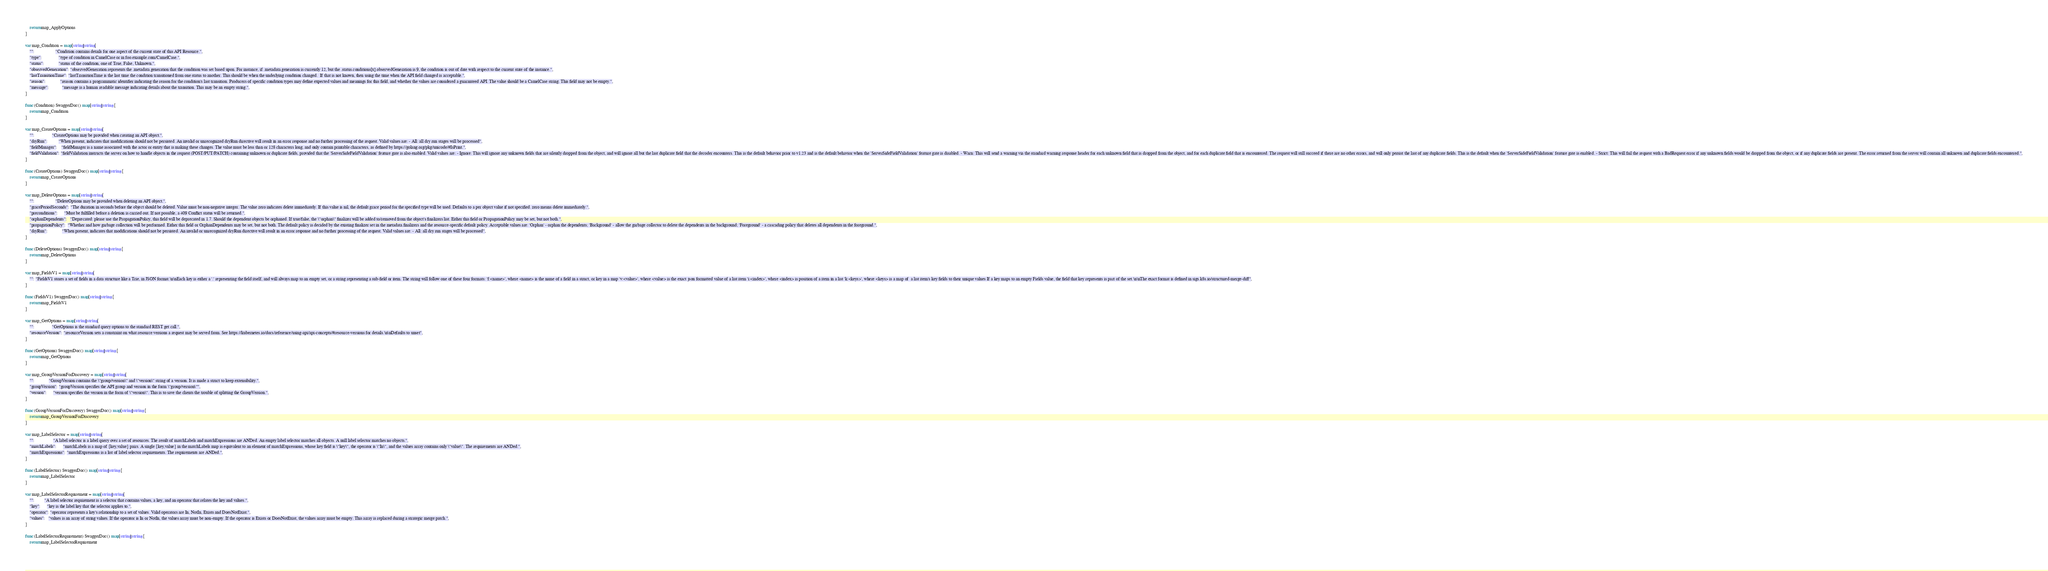Convert code to text. <code><loc_0><loc_0><loc_500><loc_500><_Go_>	return map_ApplyOptions
}

var map_Condition = map[string]string{
	"":                   "Condition contains details for one aspect of the current state of this API Resource.",
	"type":               "type of condition in CamelCase or in foo.example.com/CamelCase.",
	"status":             "status of the condition, one of True, False, Unknown.",
	"observedGeneration": "observedGeneration represents the .metadata.generation that the condition was set based upon. For instance, if .metadata.generation is currently 12, but the .status.conditions[x].observedGeneration is 9, the condition is out of date with respect to the current state of the instance.",
	"lastTransitionTime": "lastTransitionTime is the last time the condition transitioned from one status to another. This should be when the underlying condition changed.  If that is not known, then using the time when the API field changed is acceptable.",
	"reason":             "reason contains a programmatic identifier indicating the reason for the condition's last transition. Producers of specific condition types may define expected values and meanings for this field, and whether the values are considered a guaranteed API. The value should be a CamelCase string. This field may not be empty.",
	"message":            "message is a human readable message indicating details about the transition. This may be an empty string.",
}

func (Condition) SwaggerDoc() map[string]string {
	return map_Condition
}

var map_CreateOptions = map[string]string{
	"":                "CreateOptions may be provided when creating an API object.",
	"dryRun":          "When present, indicates that modifications should not be persisted. An invalid or unrecognized dryRun directive will result in an error response and no further processing of the request. Valid values are: - All: all dry run stages will be processed",
	"fieldManager":    "fieldManager is a name associated with the actor or entity that is making these changes. The value must be less than or 128 characters long, and only contain printable characters, as defined by https://golang.org/pkg/unicode/#IsPrint.",
	"fieldValidation": "fieldValidation instructs the server on how to handle objects in the request (POST/PUT/PATCH) containing unknown or duplicate fields, provided that the `ServerSideFieldValidation` feature gate is also enabled. Valid values are: - Ignore: This will ignore any unknown fields that are silently dropped from the object, and will ignore all but the last duplicate field that the decoder encounters. This is the default behavior prior to v1.23 and is the default behavior when the `ServerSideFieldValidation` feature gate is disabled. - Warn: This will send a warning via the standard warning response header for each unknown field that is dropped from the object, and for each duplicate field that is encountered. The request will still succeed if there are no other errors, and will only persist the last of any duplicate fields. This is the default when the `ServerSideFieldValidation` feature gate is enabled. - Strict: This will fail the request with a BadRequest error if any unknown fields would be dropped from the object, or if any duplicate fields are present. The error returned from the server will contain all unknown and duplicate fields encountered.",
}

func (CreateOptions) SwaggerDoc() map[string]string {
	return map_CreateOptions
}

var map_DeleteOptions = map[string]string{
	"":                   "DeleteOptions may be provided when deleting an API object.",
	"gracePeriodSeconds": "The duration in seconds before the object should be deleted. Value must be non-negative integer. The value zero indicates delete immediately. If this value is nil, the default grace period for the specified type will be used. Defaults to a per object value if not specified. zero means delete immediately.",
	"preconditions":      "Must be fulfilled before a deletion is carried out. If not possible, a 409 Conflict status will be returned.",
	"orphanDependents":   "Deprecated: please use the PropagationPolicy, this field will be deprecated in 1.7. Should the dependent objects be orphaned. If true/false, the \"orphan\" finalizer will be added to/removed from the object's finalizers list. Either this field or PropagationPolicy may be set, but not both.",
	"propagationPolicy":  "Whether and how garbage collection will be performed. Either this field or OrphanDependents may be set, but not both. The default policy is decided by the existing finalizer set in the metadata.finalizers and the resource-specific default policy. Acceptable values are: 'Orphan' - orphan the dependents; 'Background' - allow the garbage collector to delete the dependents in the background; 'Foreground' - a cascading policy that deletes all dependents in the foreground.",
	"dryRun":             "When present, indicates that modifications should not be persisted. An invalid or unrecognized dryRun directive will result in an error response and no further processing of the request. Valid values are: - All: all dry run stages will be processed",
}

func (DeleteOptions) SwaggerDoc() map[string]string {
	return map_DeleteOptions
}

var map_FieldsV1 = map[string]string{
	"": "FieldsV1 stores a set of fields in a data structure like a Trie, in JSON format.\n\nEach key is either a '.' representing the field itself, and will always map to an empty set, or a string representing a sub-field or item. The string will follow one of these four formats: 'f:<name>', where <name> is the name of a field in a struct, or key in a map 'v:<value>', where <value> is the exact json formatted value of a list item 'i:<index>', where <index> is position of a item in a list 'k:<keys>', where <keys> is a map of  a list item's key fields to their unique values If a key maps to an empty Fields value, the field that key represents is part of the set.\n\nThe exact format is defined in sigs.k8s.io/structured-merge-diff",
}

func (FieldsV1) SwaggerDoc() map[string]string {
	return map_FieldsV1
}

var map_GetOptions = map[string]string{
	"":                "GetOptions is the standard query options to the standard REST get call.",
	"resourceVersion": "resourceVersion sets a constraint on what resource versions a request may be served from. See https://kubernetes.io/docs/reference/using-api/api-concepts/#resource-versions for details.\n\nDefaults to unset",
}

func (GetOptions) SwaggerDoc() map[string]string {
	return map_GetOptions
}

var map_GroupVersionForDiscovery = map[string]string{
	"":             "GroupVersion contains the \"group/version\" and \"version\" string of a version. It is made a struct to keep extensibility.",
	"groupVersion": "groupVersion specifies the API group and version in the form \"group/version\"",
	"version":      "version specifies the version in the form of \"version\". This is to save the clients the trouble of splitting the GroupVersion.",
}

func (GroupVersionForDiscovery) SwaggerDoc() map[string]string {
	return map_GroupVersionForDiscovery
}

var map_LabelSelector = map[string]string{
	"":                 "A label selector is a label query over a set of resources. The result of matchLabels and matchExpressions are ANDed. An empty label selector matches all objects. A null label selector matches no objects.",
	"matchLabels":      "matchLabels is a map of {key,value} pairs. A single {key,value} in the matchLabels map is equivalent to an element of matchExpressions, whose key field is \"key\", the operator is \"In\", and the values array contains only \"value\". The requirements are ANDed.",
	"matchExpressions": "matchExpressions is a list of label selector requirements. The requirements are ANDed.",
}

func (LabelSelector) SwaggerDoc() map[string]string {
	return map_LabelSelector
}

var map_LabelSelectorRequirement = map[string]string{
	"":         "A label selector requirement is a selector that contains values, a key, and an operator that relates the key and values.",
	"key":      "key is the label key that the selector applies to.",
	"operator": "operator represents a key's relationship to a set of values. Valid operators are In, NotIn, Exists and DoesNotExist.",
	"values":   "values is an array of string values. If the operator is In or NotIn, the values array must be non-empty. If the operator is Exists or DoesNotExist, the values array must be empty. This array is replaced during a strategic merge patch.",
}

func (LabelSelectorRequirement) SwaggerDoc() map[string]string {
	return map_LabelSelectorRequirement</code> 